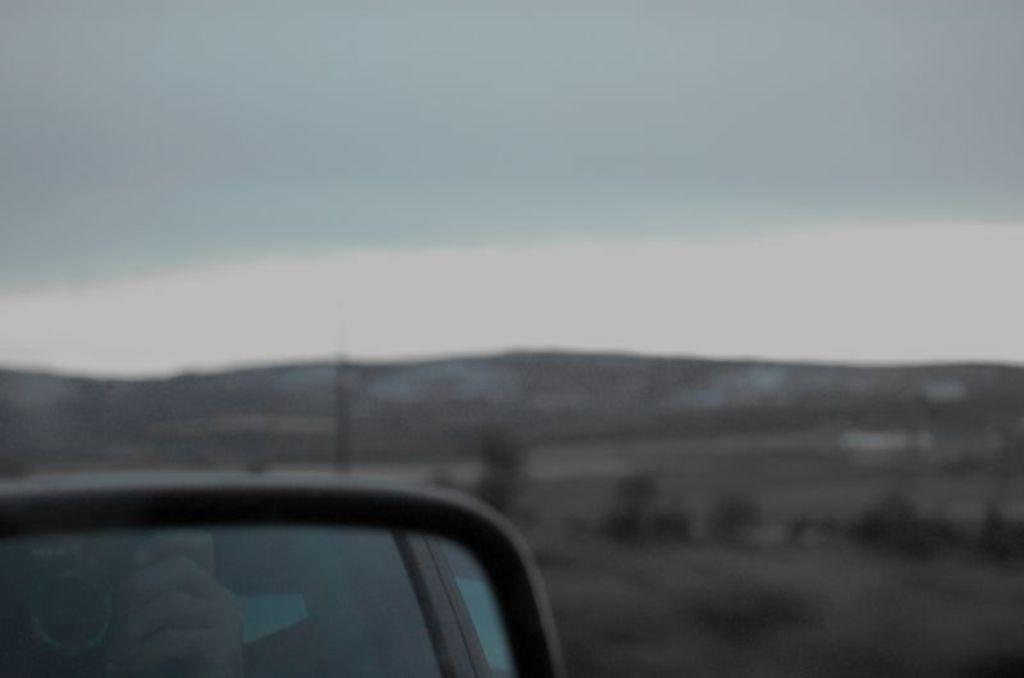What is the main subject of the image? The main subject of the image is a mirror of a vehicle. What can be seen on the ground in the image? There are plants on the ground in the image. What is visible in the background of the image? Hills and the sky are visible in the background of the image. What type of heart-shaped decoration can be seen hanging from the curtain in the image? There is no curtain or heart-shaped decoration present in the image. 